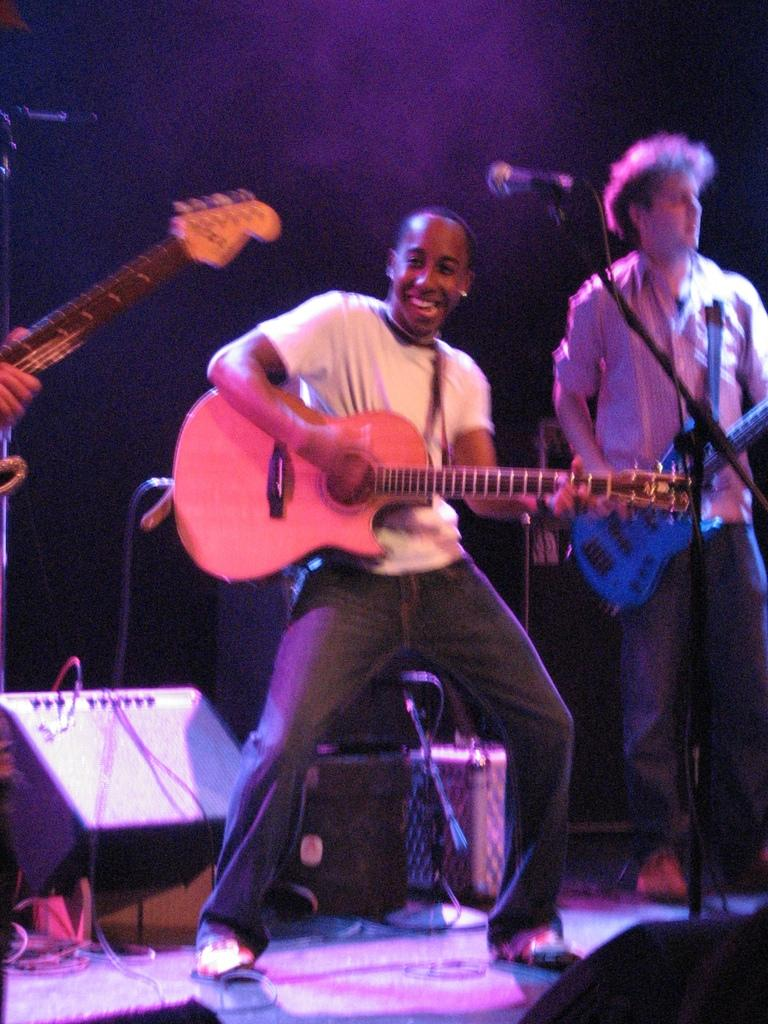How many people are in the image? There are two men in the image. What are the men holding in the image? The men are holding guitars. Can you describe the facial expression of one of the men? One of the men is smiling. What is the man standing in front of? The man is standing in front of a microphone. What can be seen in the background of the image? There are equipment and a speaker visible in the background. What type of garden can be seen in the background of the image? There is no garden present in the image; it features two men holding guitars, a microphone, and equipment in the background. Can you tell me how many sinks are visible in the image? There are no sinks visible in the image. 